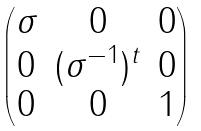Convert formula to latex. <formula><loc_0><loc_0><loc_500><loc_500>\begin{pmatrix} \sigma & 0 & 0 \\ 0 & ( \sigma ^ { - 1 } ) ^ { t } & 0 \\ 0 & 0 & 1 \end{pmatrix}</formula> 